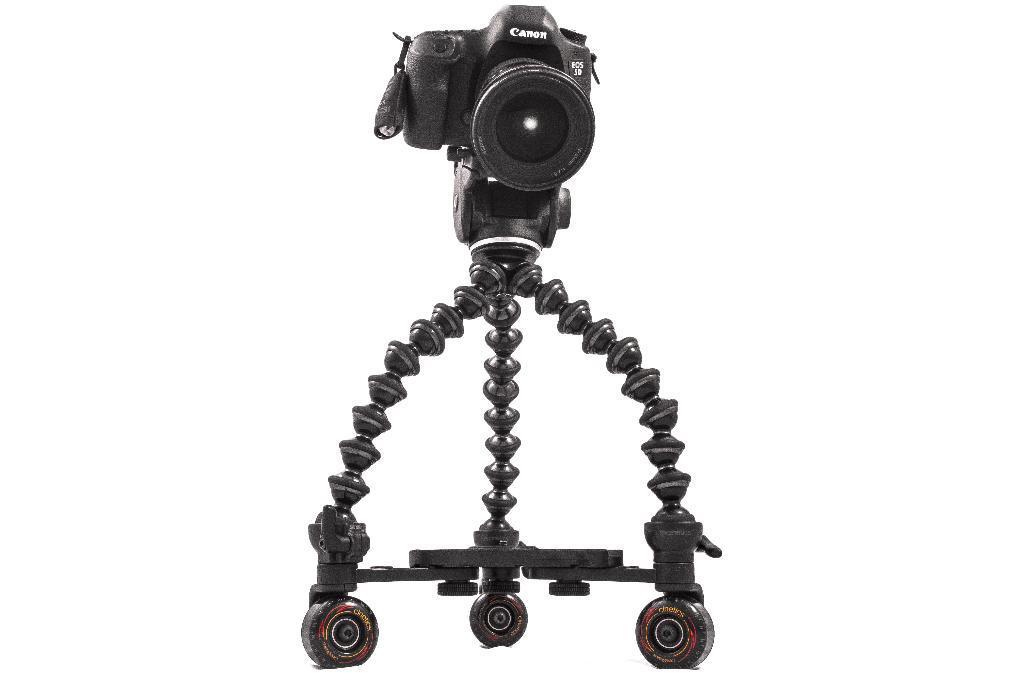Describe this image in one or two sentences. In this picture we can see a gorillapod stand, there is a camera present on the stand, we can see a white color background. 